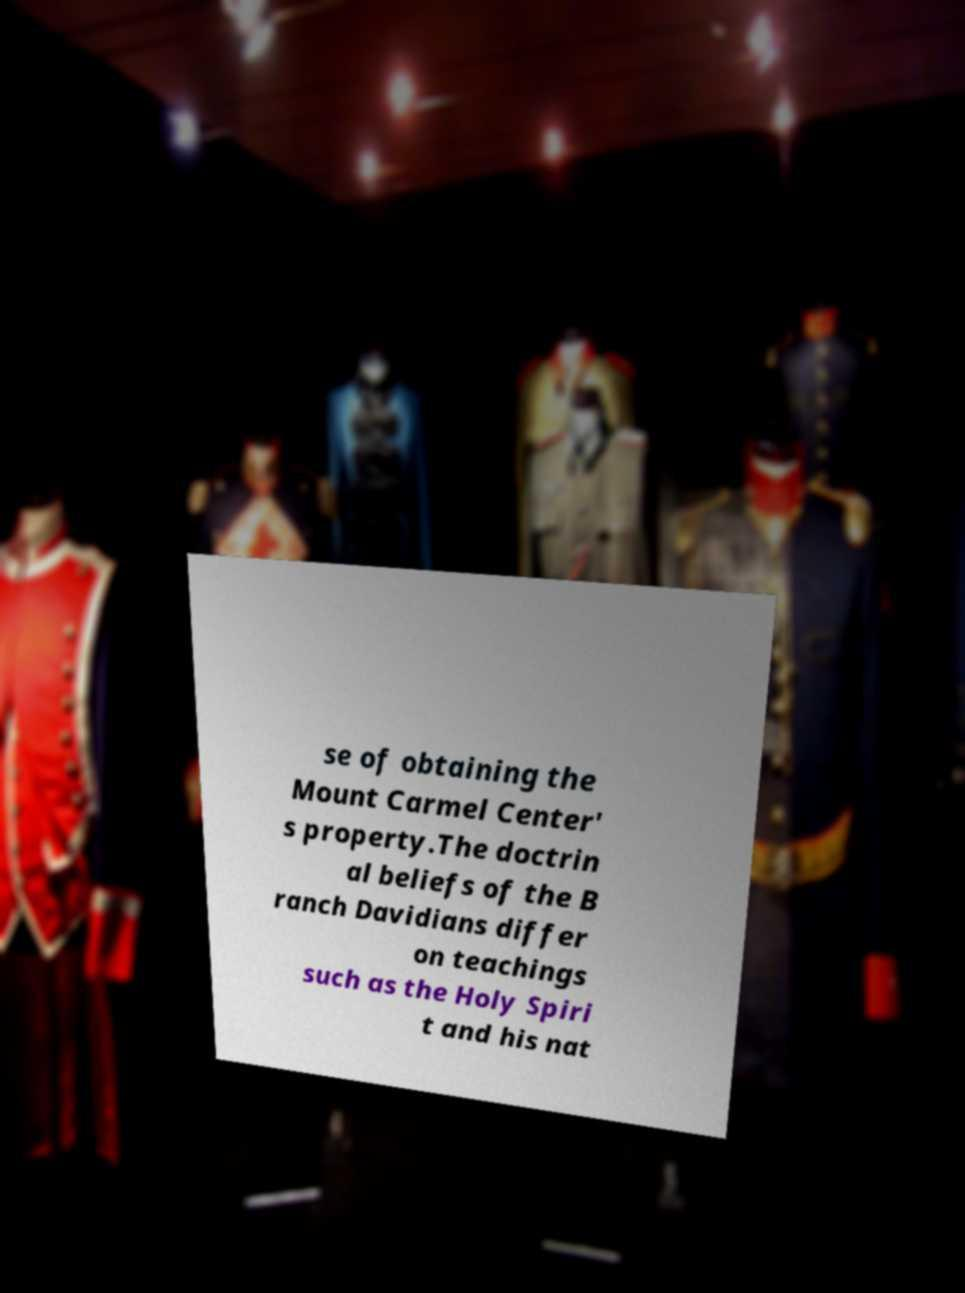Please identify and transcribe the text found in this image. se of obtaining the Mount Carmel Center' s property.The doctrin al beliefs of the B ranch Davidians differ on teachings such as the Holy Spiri t and his nat 